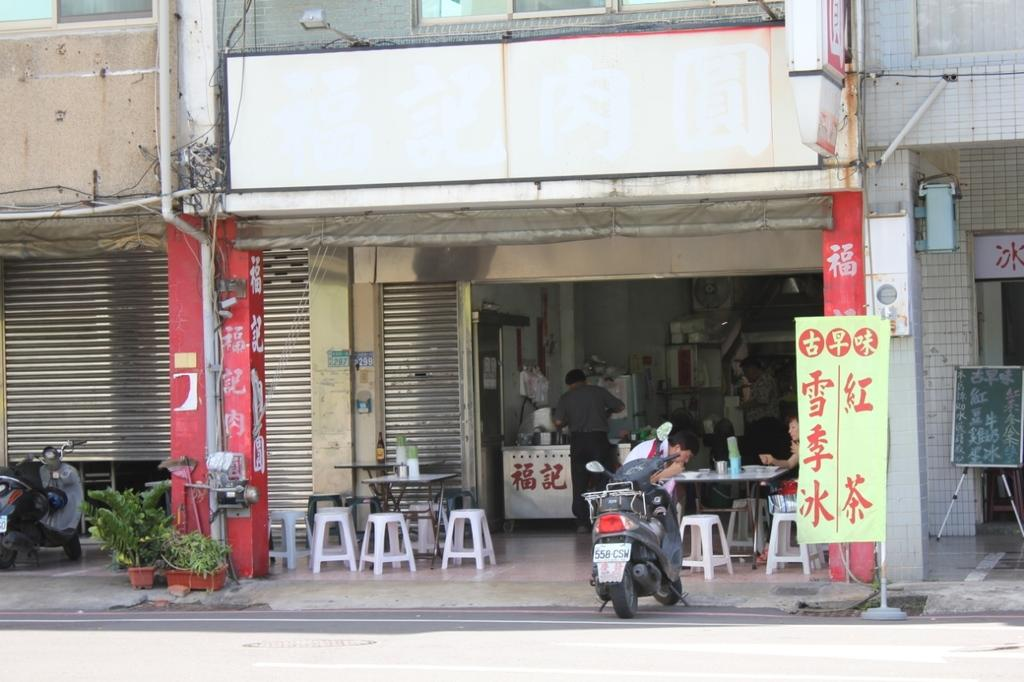What type of structure is present in the image? There is a building in the image. What can be found inside the building? There is a shop in the building. What are the people in the image doing? The people in the image are sitting on chairs. What else can be seen in the image besides the building and people? There are vehicles and potted plants visible in the image. What type of leaf is being used for learning in the image? There is no leaf present in the image, nor is there any indication of learning taking place. 